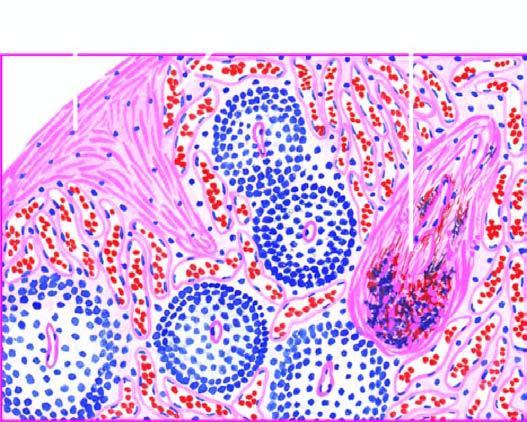s the colour of sectioned surface also seen?
Answer the question using a single word or phrase. No 